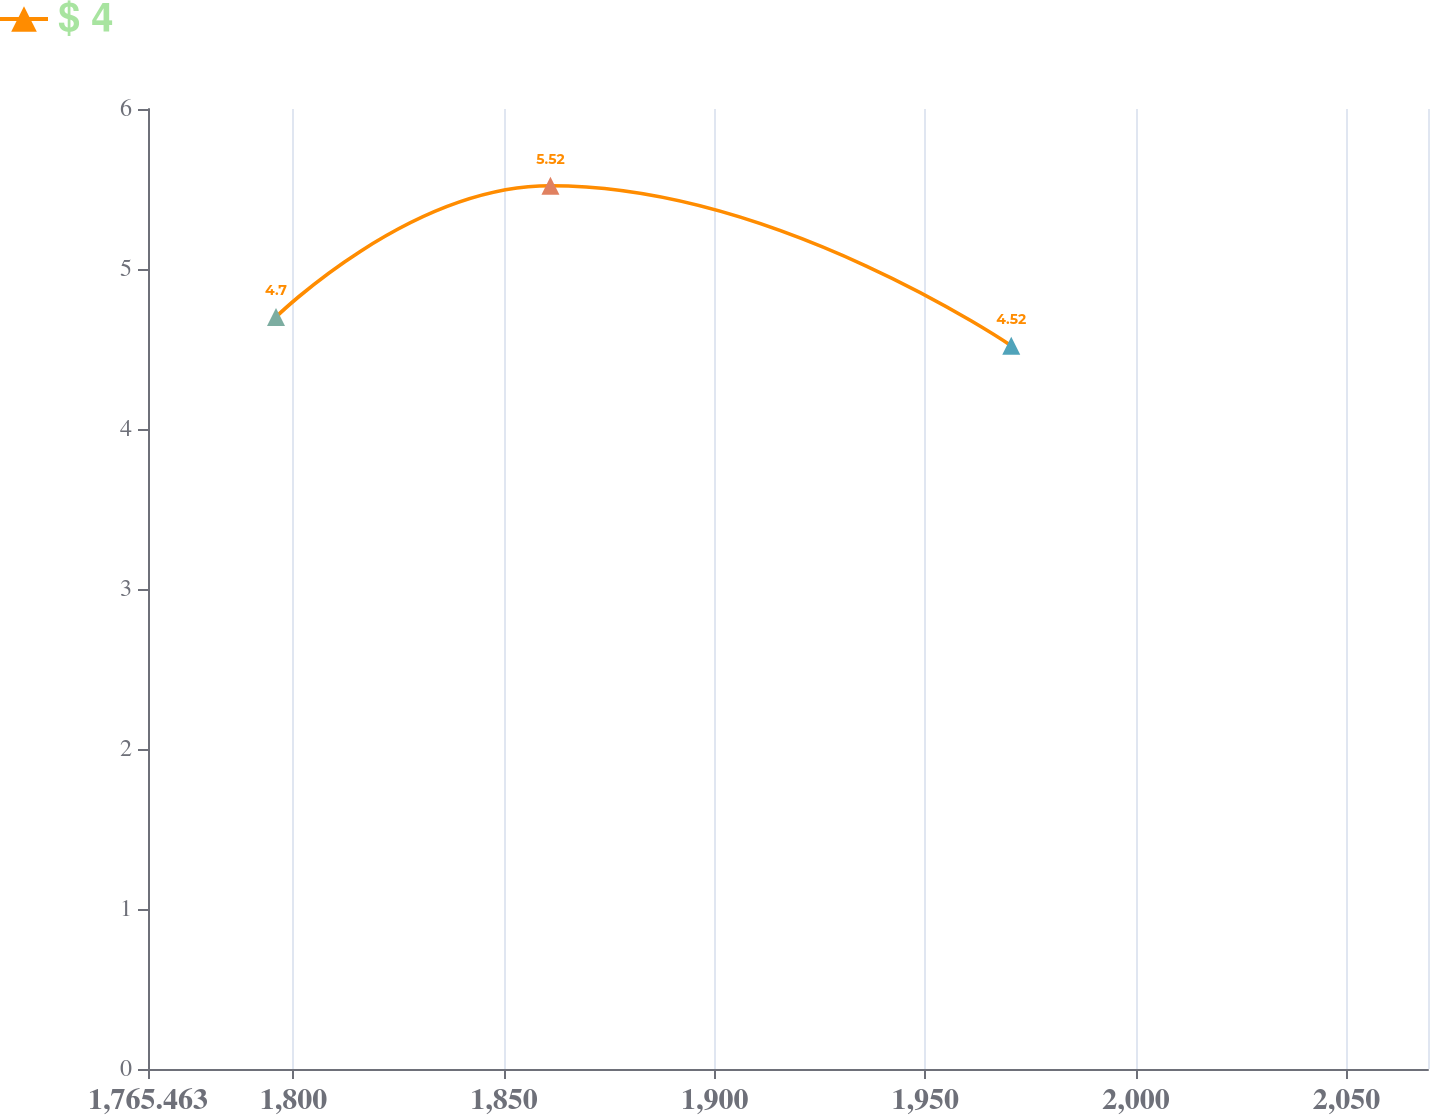<chart> <loc_0><loc_0><loc_500><loc_500><line_chart><ecel><fcel>$ 4<nl><fcel>1795.85<fcel>4.7<nl><fcel>1861<fcel>5.52<nl><fcel>1970.39<fcel>4.52<nl><fcel>2099.72<fcel>5.79<nl></chart> 